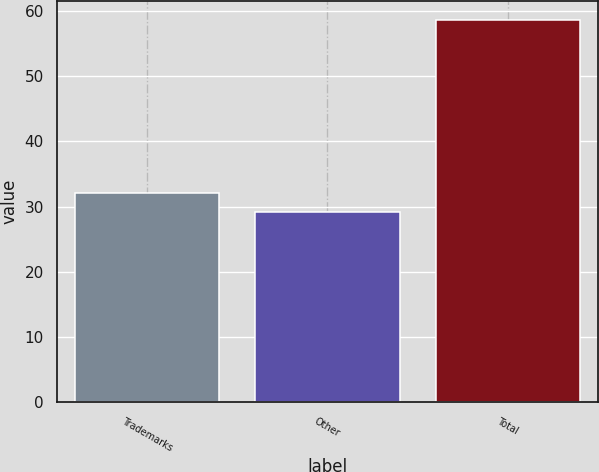Convert chart to OTSL. <chart><loc_0><loc_0><loc_500><loc_500><bar_chart><fcel>Trademarks<fcel>Other<fcel>Total<nl><fcel>32.05<fcel>29.1<fcel>58.6<nl></chart> 